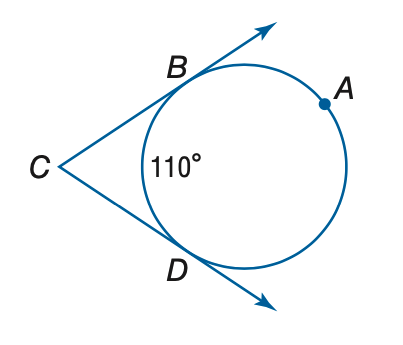Question: Find the measure of m \angle C.
Choices:
A. 35
B. 70
C. 90
D. 140
Answer with the letter. Answer: B 